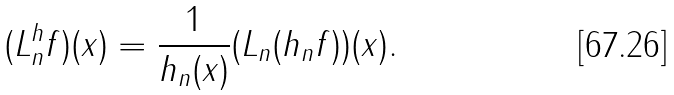Convert formula to latex. <formula><loc_0><loc_0><loc_500><loc_500>( L ^ { h } _ { n } f ) ( x ) = \frac { 1 } { h _ { n } ( x ) } ( L _ { n } ( h _ { n } f ) ) ( x ) .</formula> 